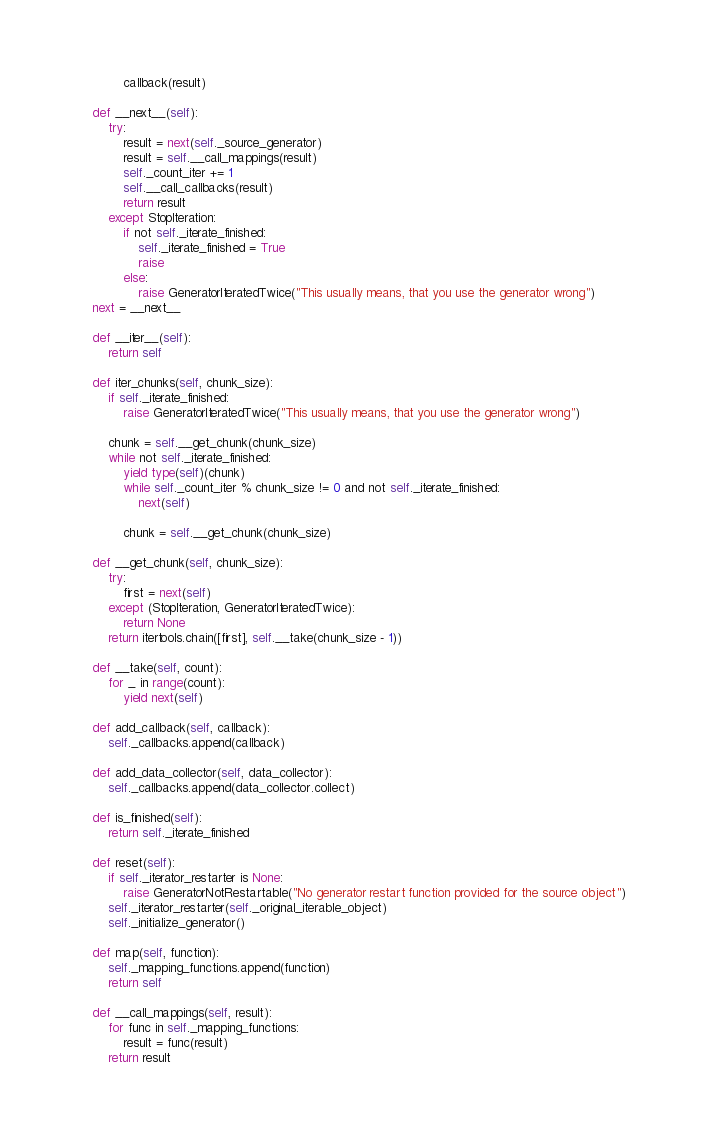Convert code to text. <code><loc_0><loc_0><loc_500><loc_500><_Python_>            callback(result)

    def __next__(self):
        try:
            result = next(self._source_generator)
            result = self.__call_mappings(result)
            self._count_iter += 1
            self.__call_callbacks(result)
            return result
        except StopIteration:
            if not self._iterate_finished:
                self._iterate_finished = True
                raise
            else:
                raise GeneratorIteratedTwice("This usually means, that you use the generator wrong")
    next = __next__

    def __iter__(self):
        return self

    def iter_chunks(self, chunk_size):
        if self._iterate_finished:
            raise GeneratorIteratedTwice("This usually means, that you use the generator wrong")

        chunk = self.__get_chunk(chunk_size)
        while not self._iterate_finished:
            yield type(self)(chunk)
            while self._count_iter % chunk_size != 0 and not self._iterate_finished:
                next(self)

            chunk = self.__get_chunk(chunk_size)

    def __get_chunk(self, chunk_size):
        try:
            first = next(self)
        except (StopIteration, GeneratorIteratedTwice):
            return None
        return itertools.chain([first], self.__take(chunk_size - 1))

    def __take(self, count):
        for _ in range(count):
            yield next(self)

    def add_callback(self, callback):
        self._callbacks.append(callback)

    def add_data_collector(self, data_collector):
        self._callbacks.append(data_collector.collect)

    def is_finished(self):
        return self._iterate_finished

    def reset(self):
        if self._iterator_restarter is None:
            raise GeneratorNotRestartable("No generator restart function provided for the source object")
        self._iterator_restarter(self._original_iterable_object)
        self._initialize_generator()

    def map(self, function):
        self._mapping_functions.append(function)
        return self

    def __call_mappings(self, result):
        for func in self._mapping_functions:
            result = func(result)
        return result
</code> 